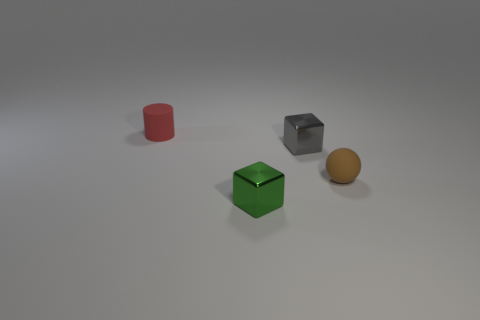Add 3 green objects. How many objects exist? 7 Subtract all spheres. How many objects are left? 3 Subtract 0 purple spheres. How many objects are left? 4 Subtract all small yellow metallic cylinders. Subtract all tiny balls. How many objects are left? 3 Add 4 tiny red cylinders. How many tiny red cylinders are left? 5 Add 4 large green metallic spheres. How many large green metallic spheres exist? 4 